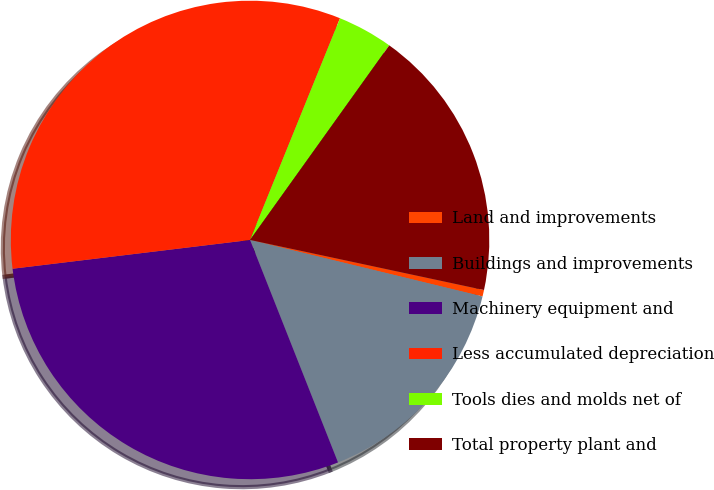Convert chart. <chart><loc_0><loc_0><loc_500><loc_500><pie_chart><fcel>Land and improvements<fcel>Buildings and improvements<fcel>Machinery equipment and<fcel>Less accumulated depreciation<fcel>Tools dies and molds net of<fcel>Total property plant and<nl><fcel>0.44%<fcel>15.21%<fcel>29.07%<fcel>33.05%<fcel>3.75%<fcel>18.47%<nl></chart> 